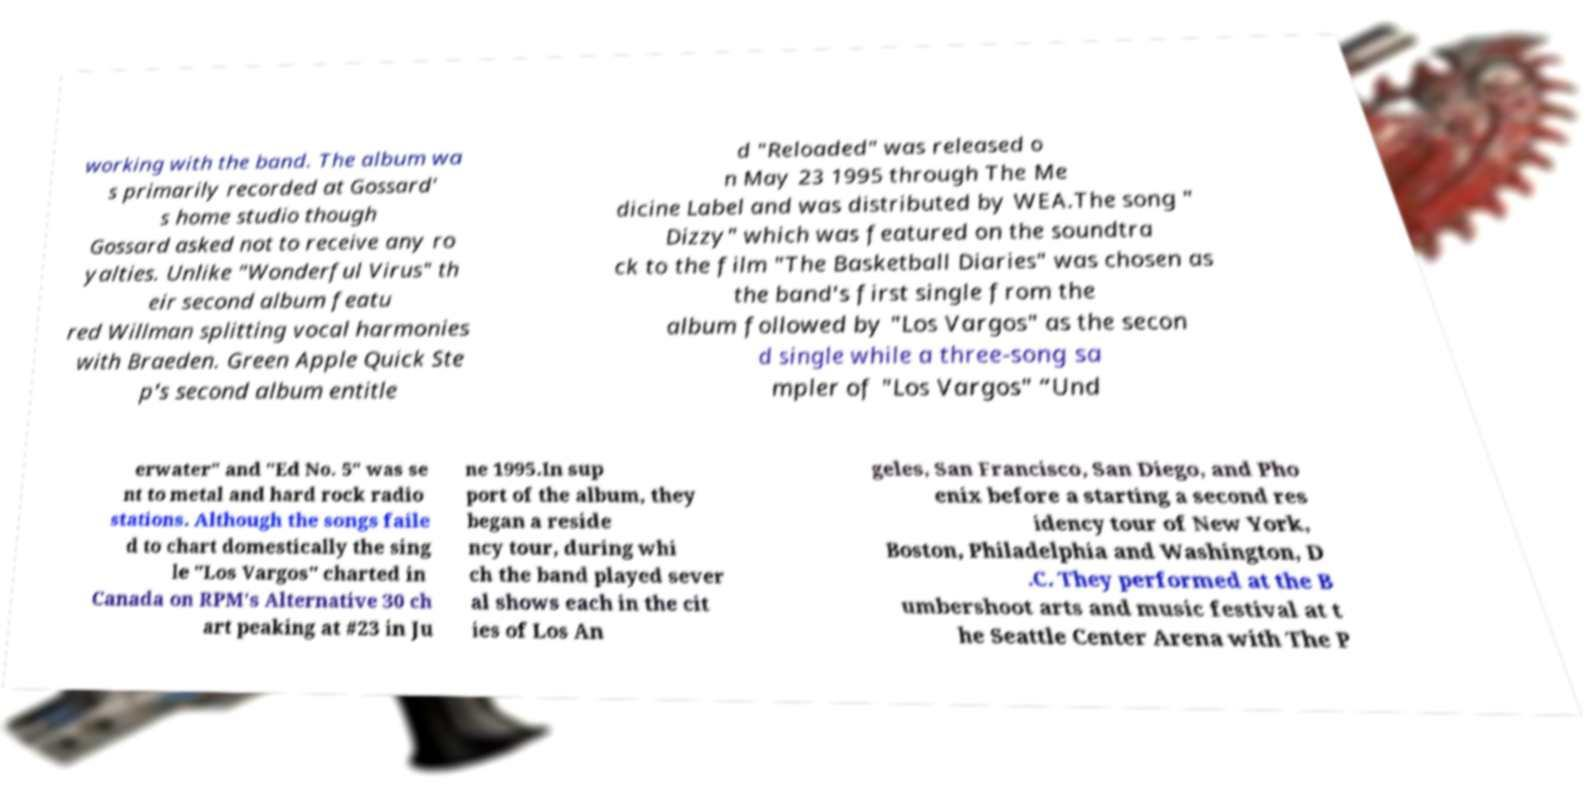Please read and relay the text visible in this image. What does it say? working with the band. The album wa s primarily recorded at Gossard' s home studio though Gossard asked not to receive any ro yalties. Unlike "Wonderful Virus" th eir second album featu red Willman splitting vocal harmonies with Braeden. Green Apple Quick Ste p's second album entitle d "Reloaded" was released o n May 23 1995 through The Me dicine Label and was distributed by WEA.The song " Dizzy" which was featured on the soundtra ck to the film "The Basketball Diaries" was chosen as the band's first single from the album followed by "Los Vargos" as the secon d single while a three-song sa mpler of "Los Vargos" “Und erwater" and "Ed No. 5" was se nt to metal and hard rock radio stations. Although the songs faile d to chart domestically the sing le "Los Vargos" charted in Canada on RPM's Alternative 30 ch art peaking at #23 in Ju ne 1995.In sup port of the album, they began a reside ncy tour, during whi ch the band played sever al shows each in the cit ies of Los An geles, San Francisco, San Diego, and Pho enix before a starting a second res idency tour of New York, Boston, Philadelphia and Washington, D .C. They performed at the B umbershoot arts and music festival at t he Seattle Center Arena with The P 